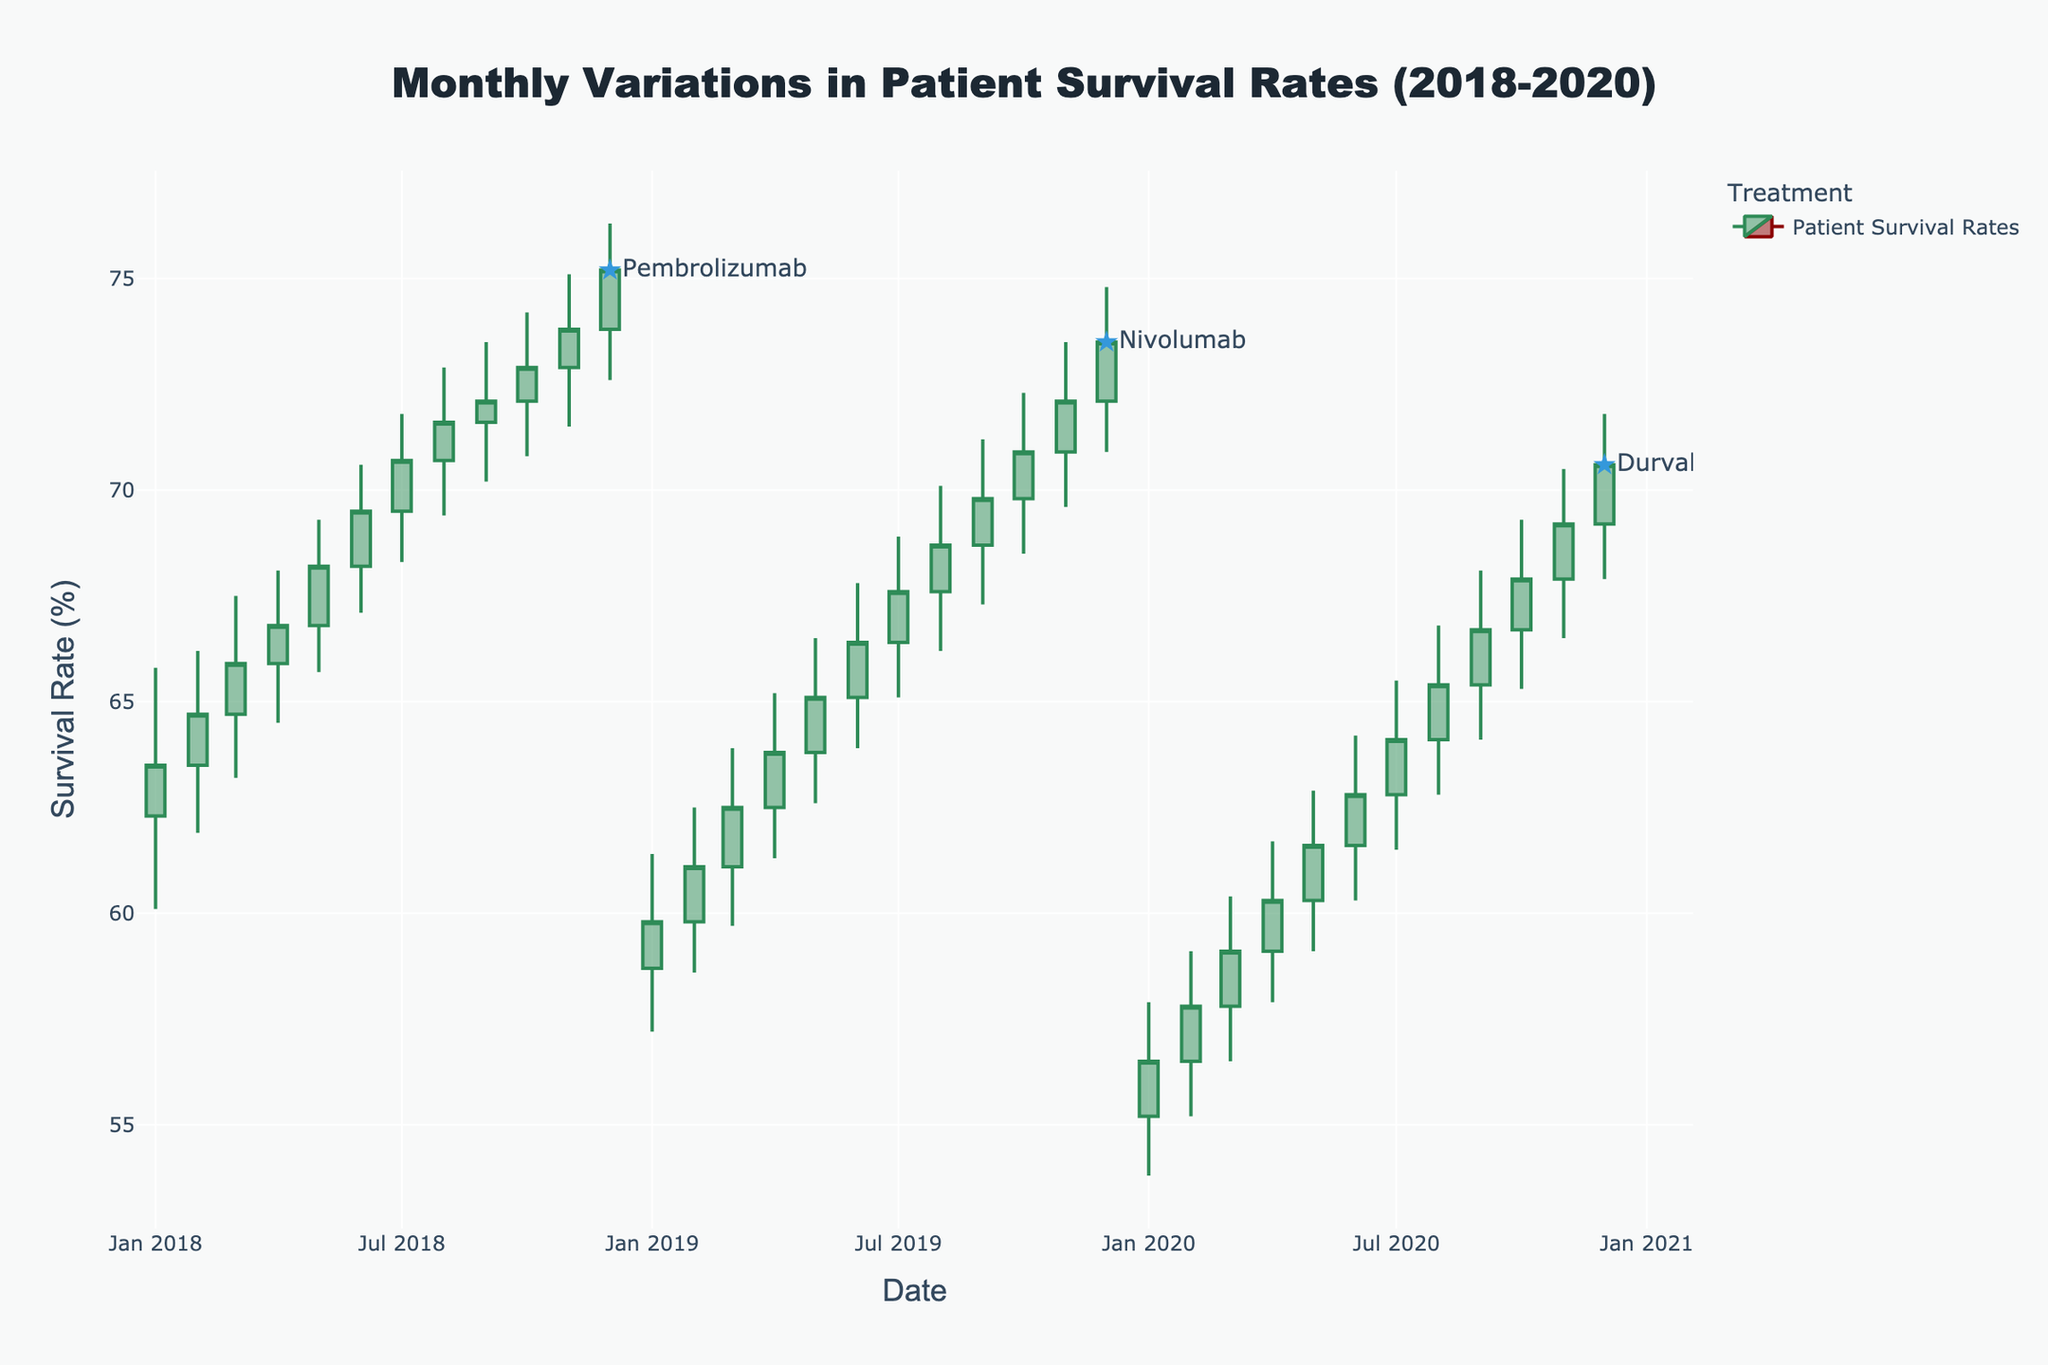What is the title of the chart? The title of the chart is displayed at the top center of the figure in large, bold text. It provides an overview of what the chart represents.
Answer: Monthly Variations in Patient Survival Rates (2018-2020) What is the period covered by this chart? To determine the period covered, examine the range of dates on the x-axis. The dates will show the starting and ending periods visible in the figure.
Answer: January 2018 to December 2020 What color represents increasing survival rates? Look at the colors of the candlesticks in the chart. The increasing survival rates are represented by the line color that looks greenish, while the decreasing rates will be in a different color.
Answer: Green Which month shows the highest patient survival rate for Pembrolizumab in 2018? Find the maximum value of the "High" segment of the candlestick for Pembrolizumab in each month of 2018 and identify the month with the highest value.
Answer: December 2018 How many different treatments are shown in the chart? Check the distinct names of treatments mentioned in the legend or the labels added to the chart.
Answer: Three What is the average "Close" survival rate for Pembrolizumab in 2018? Add up all the "Close" values for Pembrolizumab in 2018 and then divide by the number of months to get the average. \( (63.5 + 64.7 + 65.9 + 66.8 + 68.2 + 69.5 + 70.7 + 71.6 + 72.1 + 72.9 + 73.8 + 75.2) / 12 = 68.9667 \)
Answer: 69.0 Compare the survival rates of Nivolumab and Durvalumab in January of their respective starting years. Which has a higher survival rate? Locate the "Close" values for January 2019 for Nivolumab and January 2020 for Durvalumab; compare these values to see which is higher. Nivolumab's January 2019 "Close" is 59.8, and Durvalumab's January 2020 "Close" is 56.5.
Answer: Nivolumab What is the trend of survival rates for Durvalumab from January 2020 to December 2020? Note the "Open" and "Close" values for each month within the given range to observe whether the general trend is increasing or decreasing.
Answer: Increasing Which treatment had the most stable survival rates based on the highest and lowest "High" values throughout its timeline? Calculate the difference between the highest "High" and the lowest "High" for each treatment and compare them. Pembrolizumab (76.3 - 65.8 = 10.5), Nivolumab (74.8 - 61.4 = 13.4), Durvalumab (71.8 - 57.9 = 13.9). Pembrolizumab has the smallest range.
Answer: Pembrolizumab 